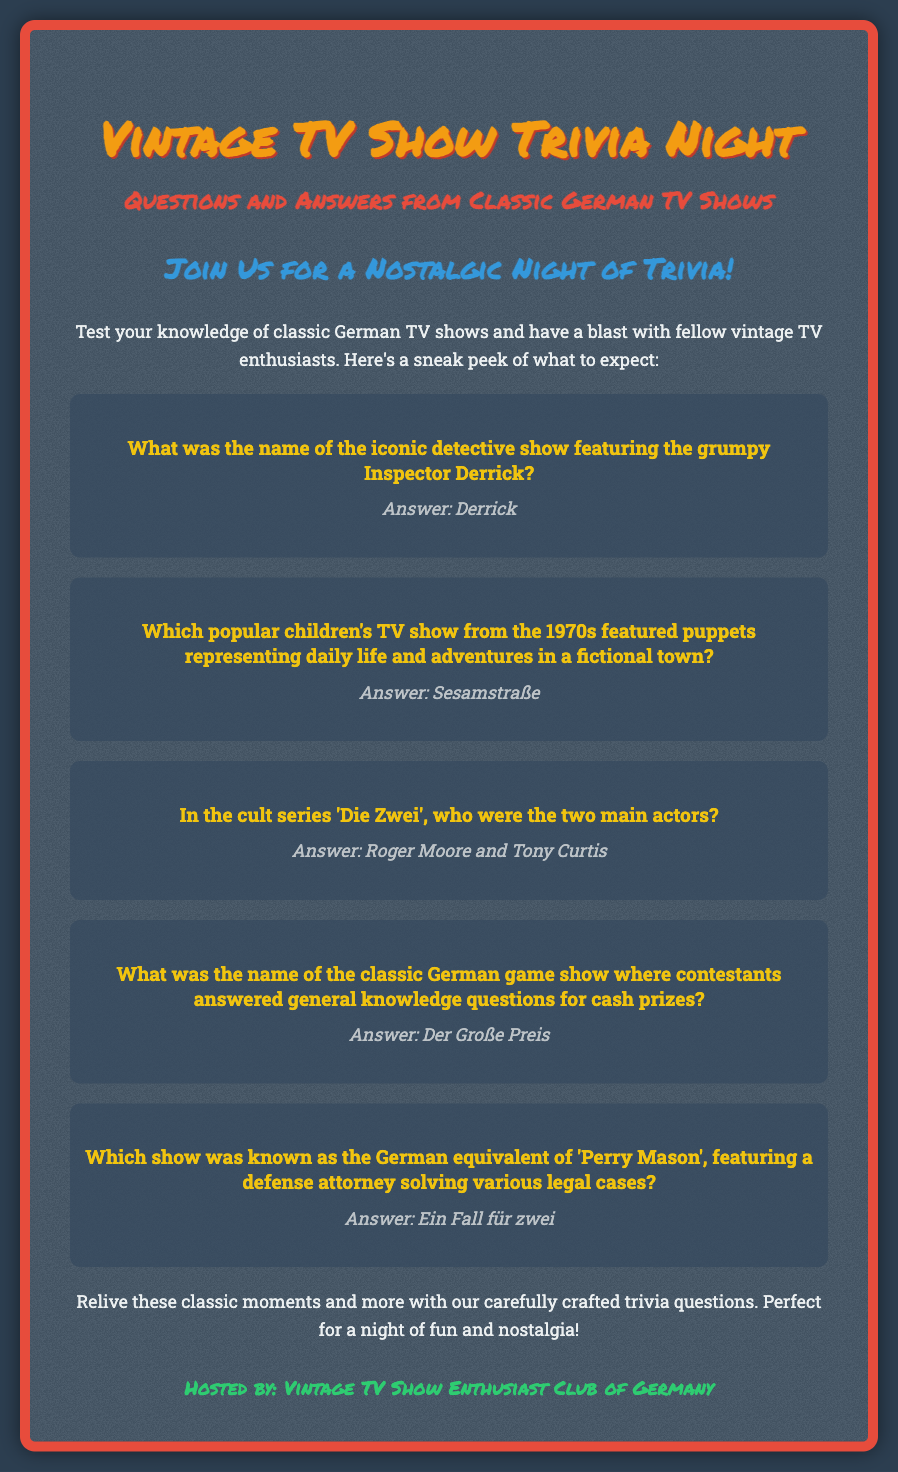What was the name of the trivia night? The trivia night is titled "Vintage TV Show Trivia Night."
Answer: Vintage TV Show Trivia Night What is the theme of the trivia questions? The trivia questions are based on classic German TV shows.
Answer: Classic German TV Shows Which show featured the grumpy Inspector Derrick? The document mentions "Derrick" as the iconic detective show.
Answer: Derrick What children's TV show aired in the 1970s? The document states that "Sesamstraße" was the popular children's show from the 1970s.
Answer: Sesamstraße Who were the two main actors in 'Die Zwei'? According to the document, the main actors were Roger Moore and Tony Curtis.
Answer: Roger Moore and Tony Curtis What is the name of the classic game show for cash prizes? The game show referred to in the document is "Der Große Preis."
Answer: Der Große Preis Which legal show is known as the German equivalent of 'Perry Mason'? The document identifies "Ein Fall für zwei" as the equivalent show.
Answer: Ein Fall für zwei Who is hosting the trivia night? The poster indicates that the event is hosted by the "Vintage TV Show Enthusiast Club of Germany."
Answer: Vintage TV Show Enthusiast Club of Germany 